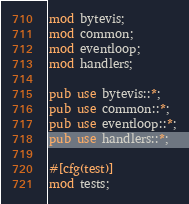Convert code to text. <code><loc_0><loc_0><loc_500><loc_500><_Rust_>mod bytevis;
mod common;
mod eventloop;
mod handlers;

pub use bytevis::*;
pub use common::*;
pub use eventloop::*;
pub use handlers::*;

#[cfg(test)]
mod tests;
</code> 